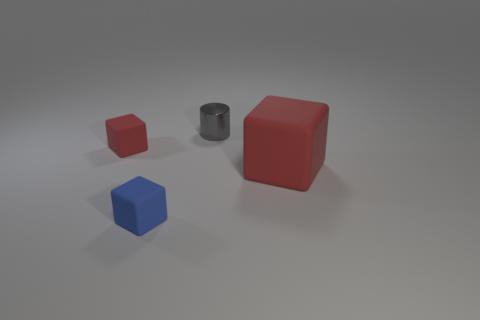There is another object that is the same color as the large thing; what is its size?
Offer a terse response. Small. Do the thing that is on the right side of the tiny cylinder and the tiny cylinder have the same color?
Provide a succinct answer. No. What is the material of the tiny cube that is the same color as the large rubber object?
Provide a succinct answer. Rubber. Do the matte object that is right of the gray metallic thing and the gray metal object have the same size?
Your answer should be compact. No. Are there any other metal things that have the same color as the metal object?
Ensure brevity in your answer.  No. There is a red cube on the left side of the gray metallic cylinder; are there any red objects that are right of it?
Offer a terse response. Yes. Is there a red block that has the same material as the small gray cylinder?
Your answer should be very brief. No. There is a red block that is in front of the rubber object that is behind the large red matte cube; what is its material?
Offer a very short reply. Rubber. There is a cube that is both right of the tiny red object and on the left side of the small gray cylinder; what is its material?
Offer a very short reply. Rubber. Are there the same number of blue objects that are to the left of the tiny blue thing and gray shiny things?
Your response must be concise. No. 